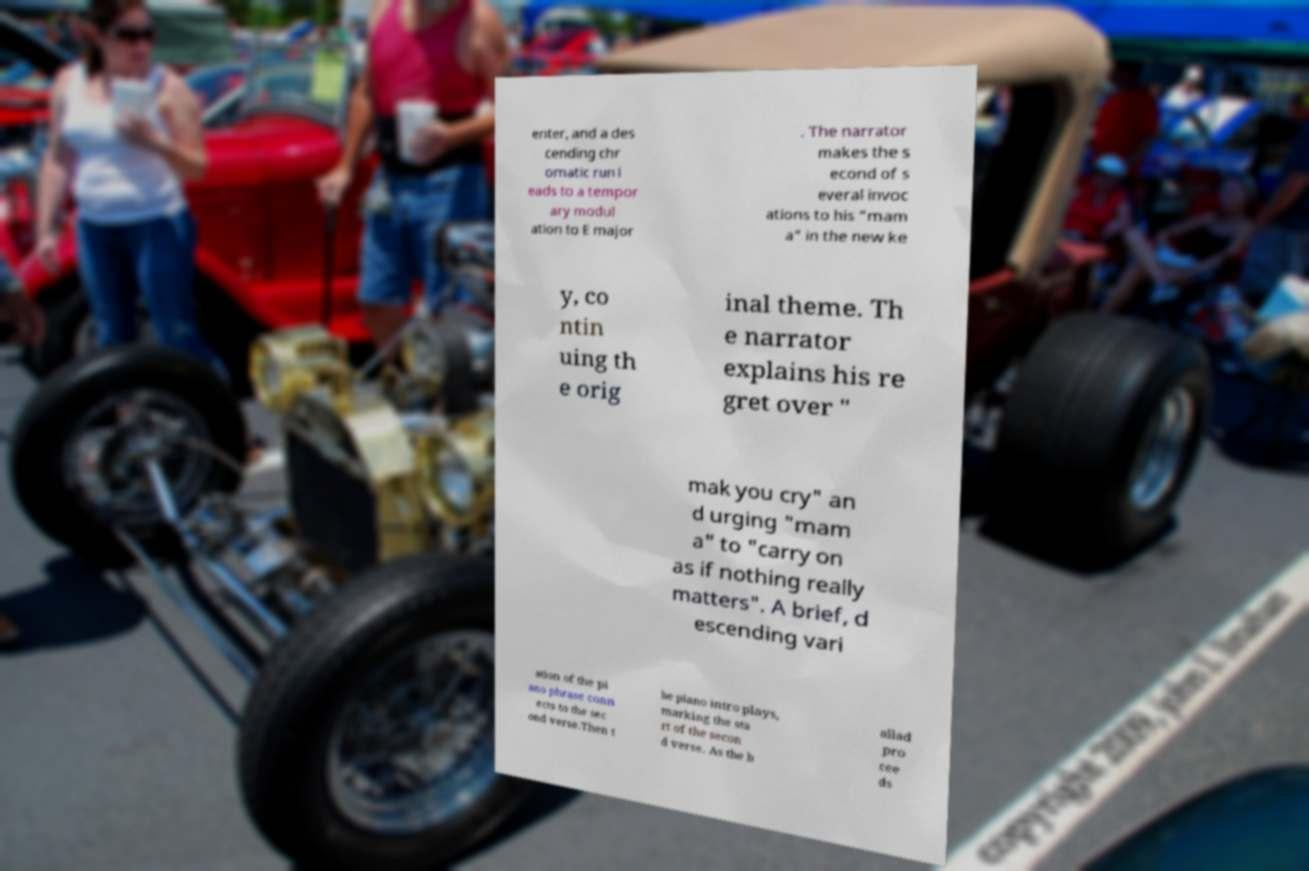Can you accurately transcribe the text from the provided image for me? enter, and a des cending chr omatic run l eads to a tempor ary modul ation to E major . The narrator makes the s econd of s everal invoc ations to his "mam a" in the new ke y, co ntin uing th e orig inal theme. Th e narrator explains his re gret over " mak you cry" an d urging "mam a" to "carry on as if nothing really matters". A brief, d escending vari ation of the pi ano phrase conn ects to the sec ond verse.Then t he piano intro plays, marking the sta rt of the secon d verse. As the b allad pro cee ds 